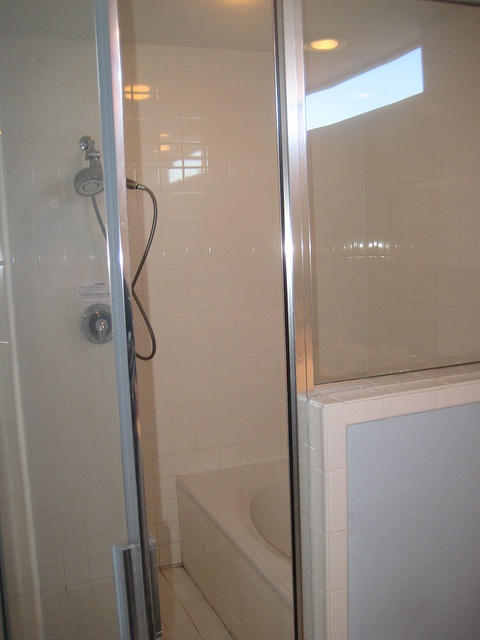Describe the objects in this image and their specific colors. I can see a toilet in gray tones in this image. 